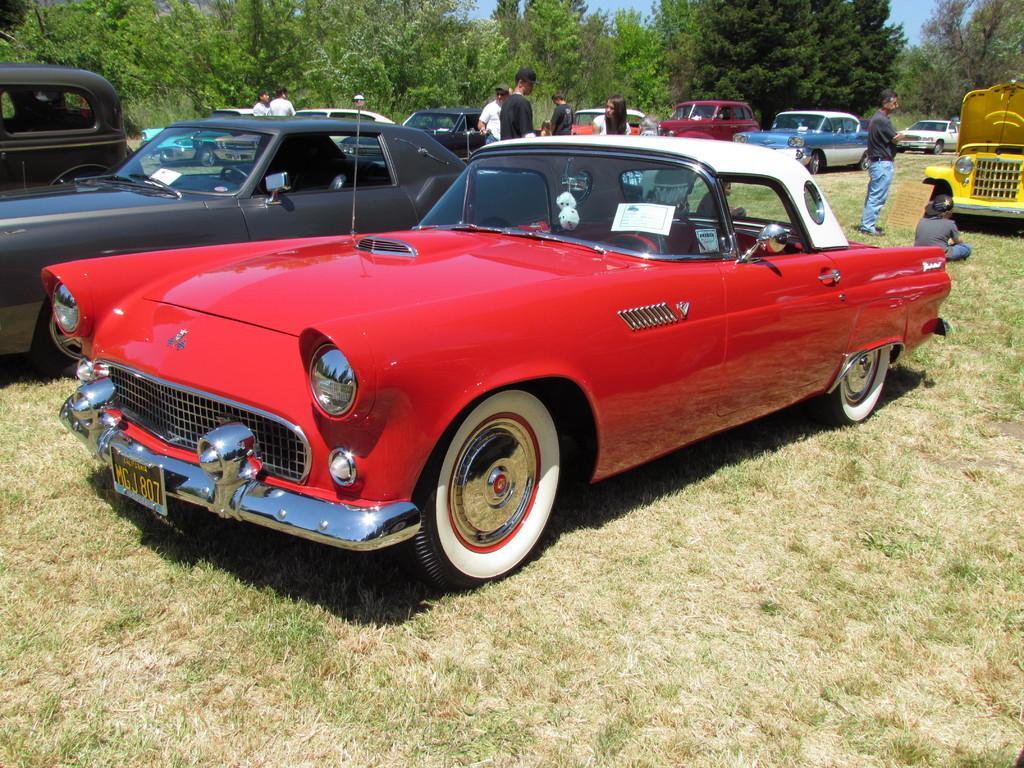In one or two sentences, can you explain what this image depicts? In this image we can see people standing on the ground and motor vehicles. In the background there are trees and sky. 